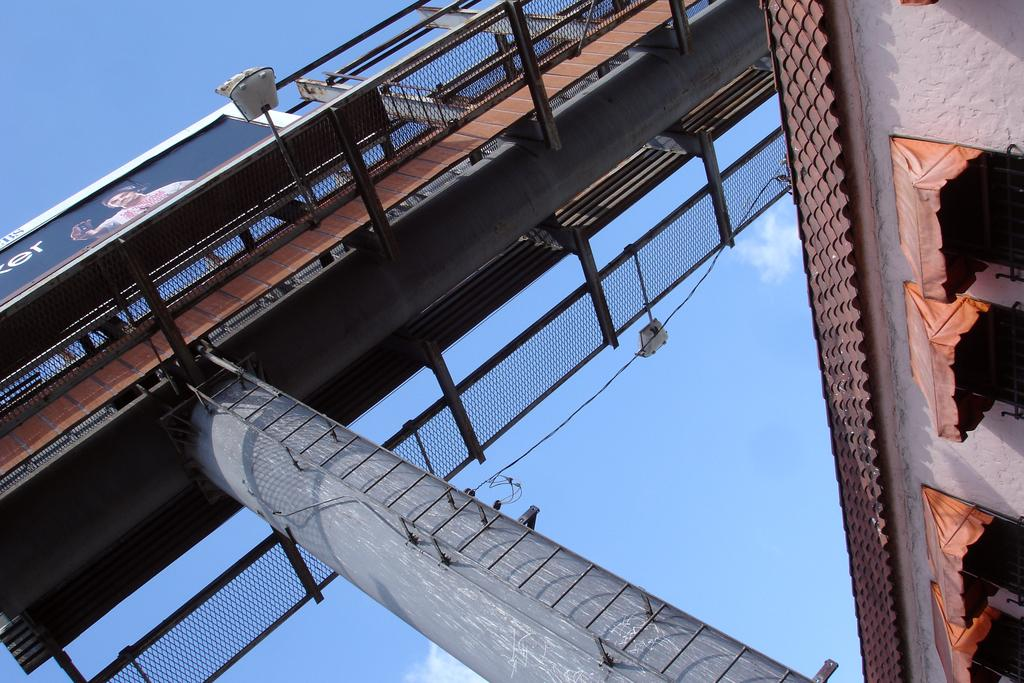What type of structure can be seen in the image? There is a bridge in the image. What other objects are present in the image? There is a board and a shed on the right side of the image. What type of temporary shelter is visible in the image? There are tents in the image. What can be seen in the background of the image? The sky is visible in the background of the image. What historical event is being commemorated by the kitten in the image? There is no kitten present in the image, and therefore no historical event can be associated with it. 